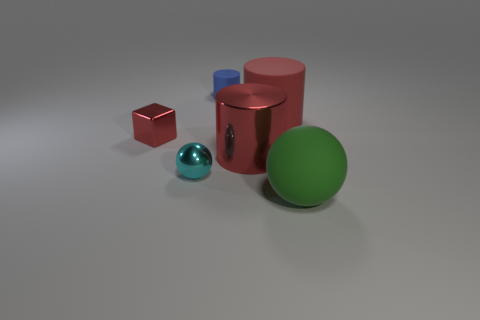Is there a big rubber cylinder of the same color as the block?
Make the answer very short. Yes. There is a large green rubber thing right of the big matte cylinder; what is its shape?
Provide a short and direct response. Sphere. There is a big matte thing that is behind the tiny red shiny thing; does it have the same color as the small cube?
Your answer should be compact. Yes. Are there fewer small blue objects to the left of the red metal cylinder than red objects?
Your answer should be very brief. Yes. What color is the tiny object that is the same material as the small sphere?
Offer a very short reply. Red. There is a matte thing in front of the cyan shiny object; how big is it?
Keep it short and to the point. Large. Is the small red block made of the same material as the blue cylinder?
Provide a short and direct response. No. There is a large rubber thing right of the big thing behind the tiny red metallic cube; are there any tiny cyan metal balls left of it?
Ensure brevity in your answer.  Yes. What is the color of the metal ball?
Give a very brief answer. Cyan. The cylinder that is the same size as the red metal block is what color?
Your answer should be compact. Blue. 